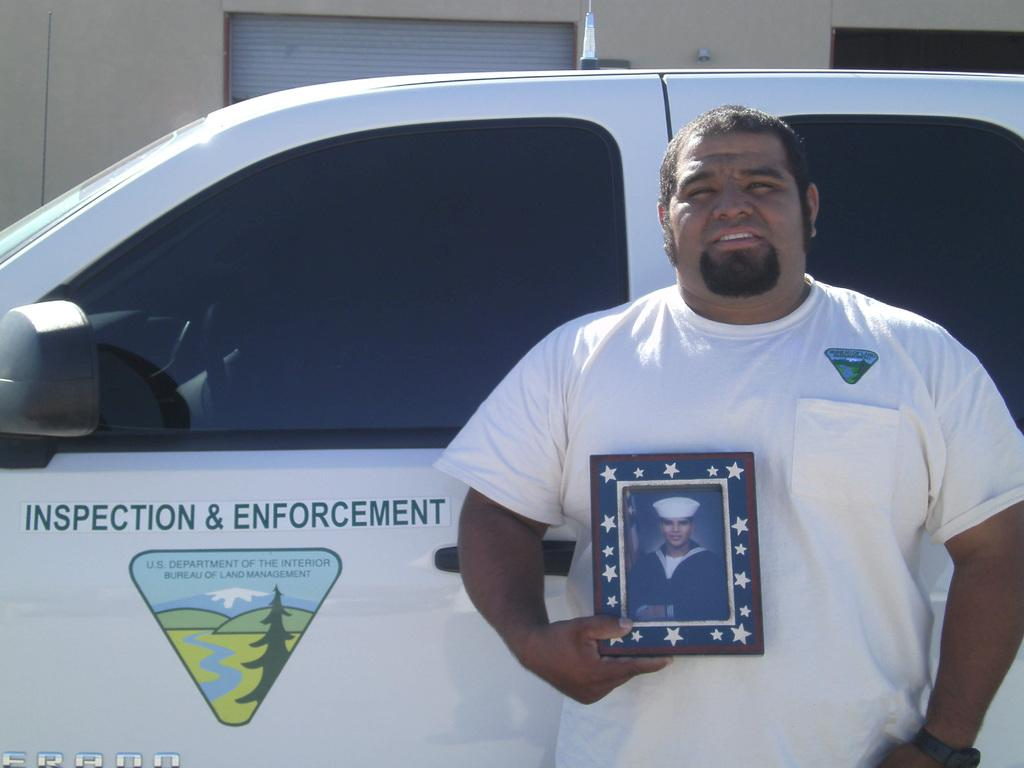What is the main subject of the image? The main subject of the image is a car. Can you describe the car in the image? The car is white in color. What is the man in the image doing? The man is standing and holding a photo frame. What can be seen in the background of the image? There is a building visible in the background of the image. What type of cream is being used to treat the disease in the image? There is no mention of cream or disease in the image; it features a car, a man holding a photo frame, and a building in the background. 